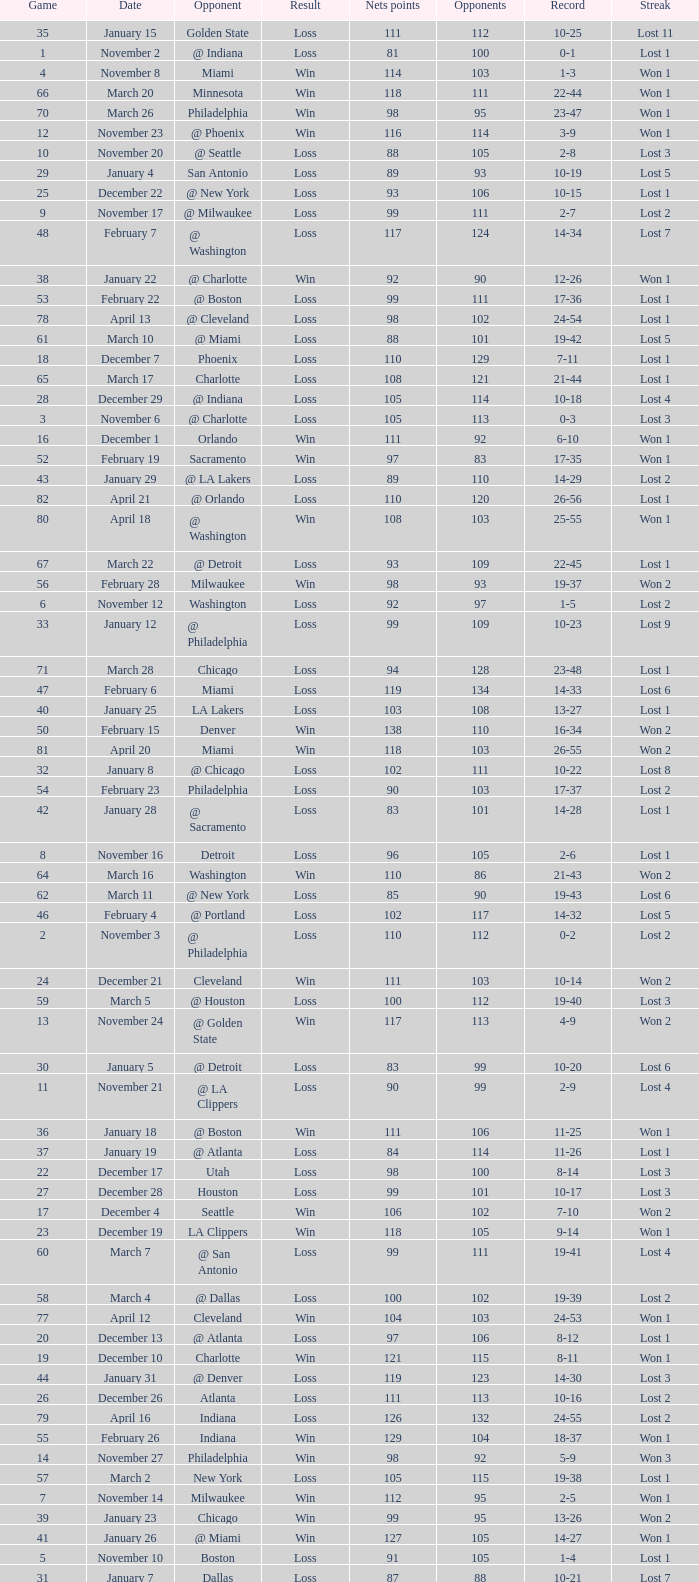In which game did the opponent score more than 103 and the record was 1-3? None. 